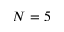Convert formula to latex. <formula><loc_0><loc_0><loc_500><loc_500>N = 5</formula> 